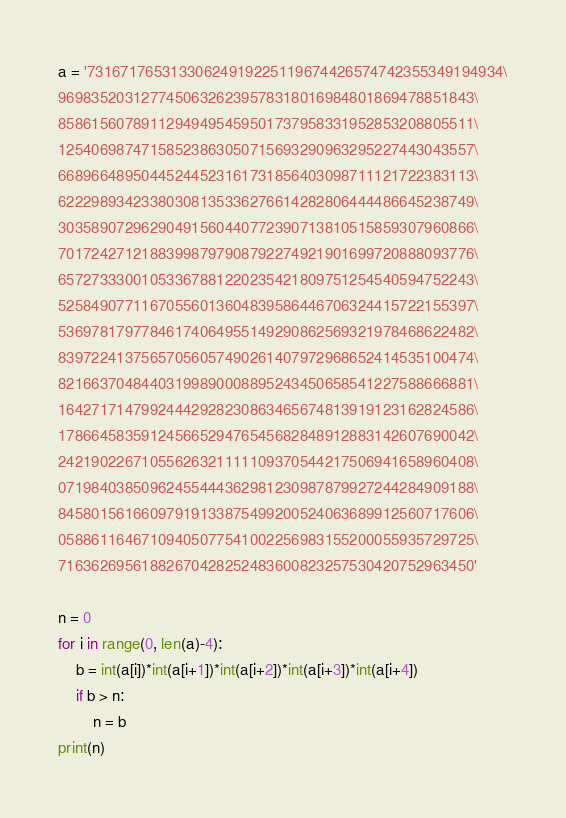Convert code to text. <code><loc_0><loc_0><loc_500><loc_500><_Python_>a = '73167176531330624919225119674426574742355349194934\
96983520312774506326239578318016984801869478851843\
85861560789112949495459501737958331952853208805511\
12540698747158523863050715693290963295227443043557\
66896648950445244523161731856403098711121722383113\
62229893423380308135336276614282806444486645238749\
30358907296290491560440772390713810515859307960866\
70172427121883998797908792274921901699720888093776\
65727333001053367881220235421809751254540594752243\
52584907711670556013604839586446706324415722155397\
53697817977846174064955149290862569321978468622482\
83972241375657056057490261407972968652414535100474\
82166370484403199890008895243450658541227588666881\
16427171479924442928230863465674813919123162824586\
17866458359124566529476545682848912883142607690042\
24219022671055626321111109370544217506941658960408\
07198403850962455444362981230987879927244284909188\
84580156166097919133875499200524063689912560717606\
05886116467109405077541002256983155200055935729725\
71636269561882670428252483600823257530420752963450'

n = 0
for i in range(0, len(a)-4):
    b = int(a[i])*int(a[i+1])*int(a[i+2])*int(a[i+3])*int(a[i+4])
    if b > n:
        n = b
print(n)


</code> 